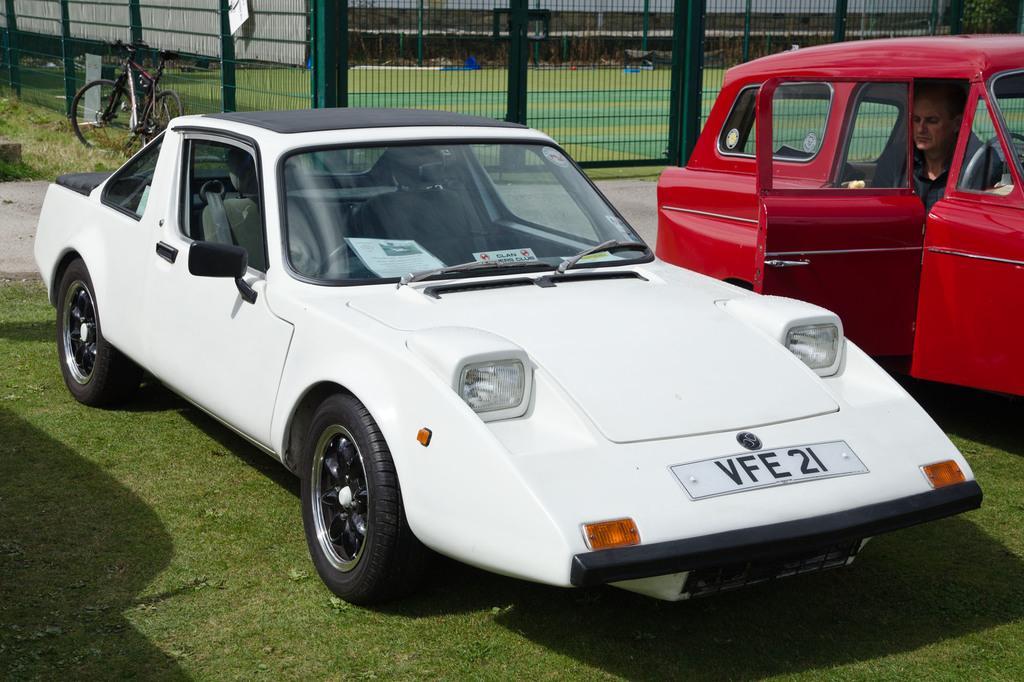In one or two sentences, can you explain what this image depicts? In this image in the foreground there are two cars and one person is sitting in one car, in the background there is a fence, cycle and some poles, trees. At the bottom there is grass. 